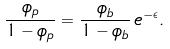<formula> <loc_0><loc_0><loc_500><loc_500>\frac { \phi _ { p } } { 1 - \phi _ { p } } = \frac { \phi _ { b } } { 1 - \phi _ { b } } \, e ^ { - \epsilon } .</formula> 